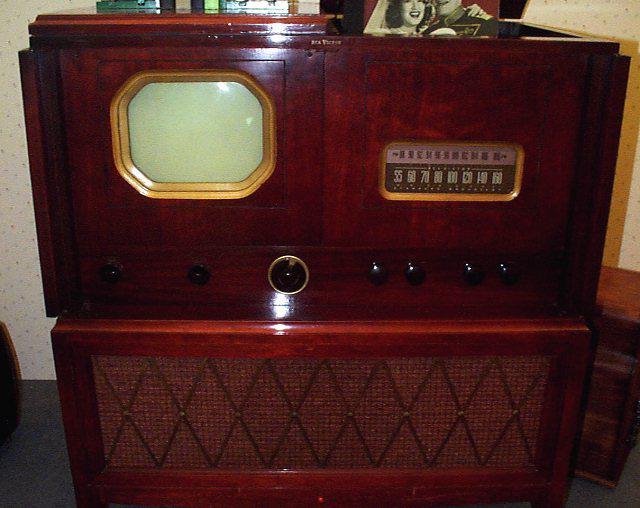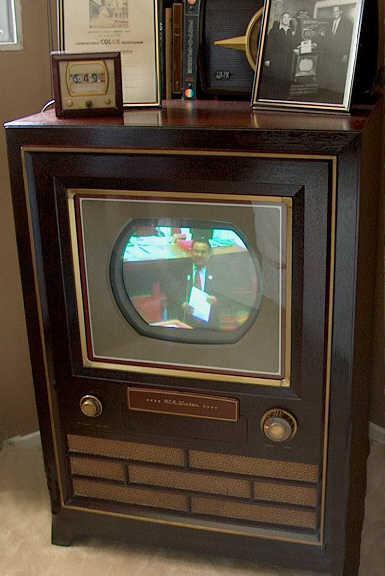The first image is the image on the left, the second image is the image on the right. For the images shown, is this caption "Both TVs feature small non-square screens set in boxy wood consoles, and one has a picture playing on its screen, while the other has a rich cherry finish console." true? Answer yes or no. Yes. The first image is the image on the left, the second image is the image on the right. Considering the images on both sides, is "Two console televison cabinets in dark wood feature a picture tube in the upper section and speakers housed in the bottom section." valid? Answer yes or no. Yes. 